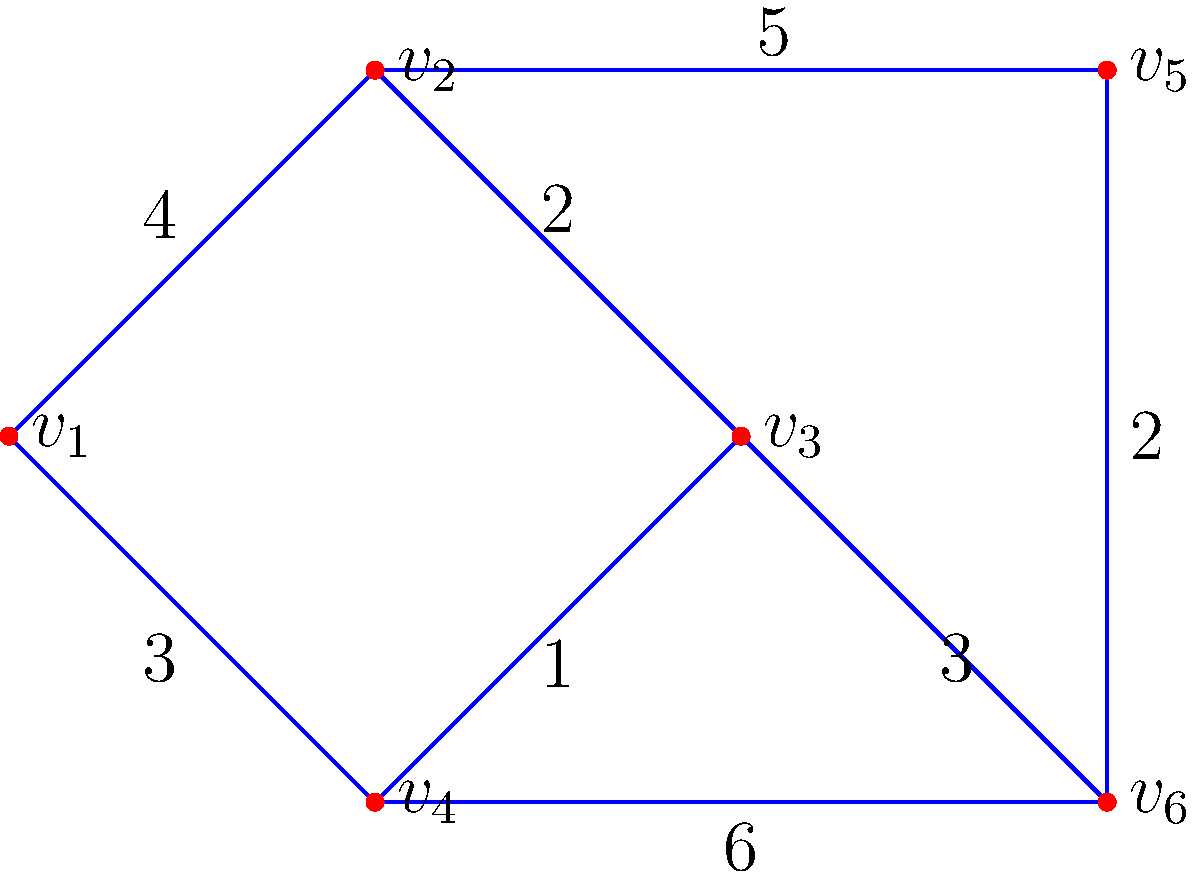Given the connected graph above with 6 vertices and 8 edges, determine the total weight of the minimum spanning tree using Kruskal's algorithm. List the edges in the order they are added to the minimum spanning tree. To find the minimum spanning tree using Kruskal's algorithm, we follow these steps:

1. Sort all edges by weight in ascending order:
   $(v_2, v_3)$ : 1
   $(v_1, v_2)$ and $(v_4, v_5)$ : 2
   $(v_0, v_3)$ and $(v_2, v_5)$ : 3
   $(v_0, v_1)$ : 4
   $(v_1, v_4)$ : 5
   $(v_3, v_5)$ : 6

2. Start with an empty set of edges and add edges in order, skipping those that would create a cycle:

   a. Add $(v_2, v_3)$ : weight 1
   b. Add $(v_1, v_2)$ : weight 2
   c. Add $(v_4, v_5)$ : weight 2
   d. Add $(v_0, v_3)$ : weight 3
   e. Add $(v_1, v_4)$ : weight 5

3. After adding these 5 edges, we have connected all 6 vertices without creating any cycles. This forms our minimum spanning tree.

4. Calculate the total weight: $1 + 2 + 2 + 3 + 5 = 13$

Therefore, the minimum spanning tree has a total weight of 13, and the edges are added in the order: $(v_2, v_3)$, $(v_1, v_2)$, $(v_4, v_5)$, $(v_0, v_3)$, $(v_1, v_4)$.
Answer: Total weight: 13; Edges: $(v_2, v_3)$, $(v_1, v_2)$, $(v_4, v_5)$, $(v_0, v_3)$, $(v_1, v_4)$ 